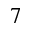Convert formula to latex. <formula><loc_0><loc_0><loc_500><loc_500>7</formula> 